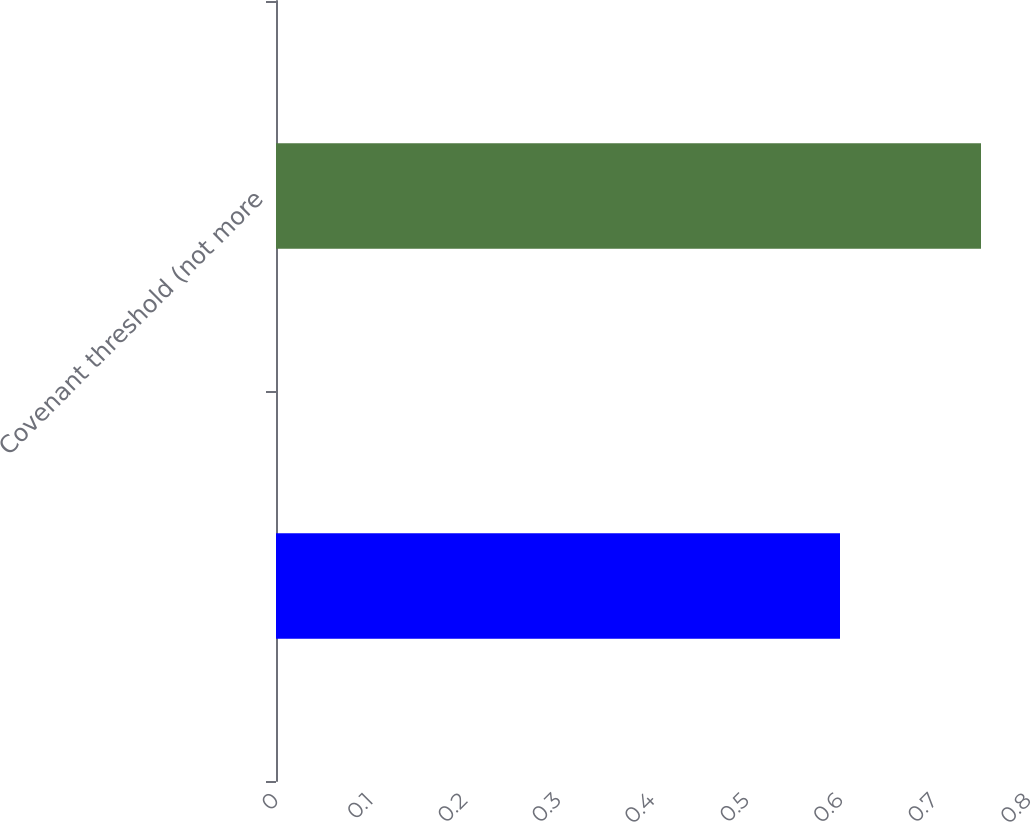Convert chart to OTSL. <chart><loc_0><loc_0><loc_500><loc_500><bar_chart><ecel><fcel>Covenant threshold (not more<nl><fcel>0.6<fcel>0.75<nl></chart> 